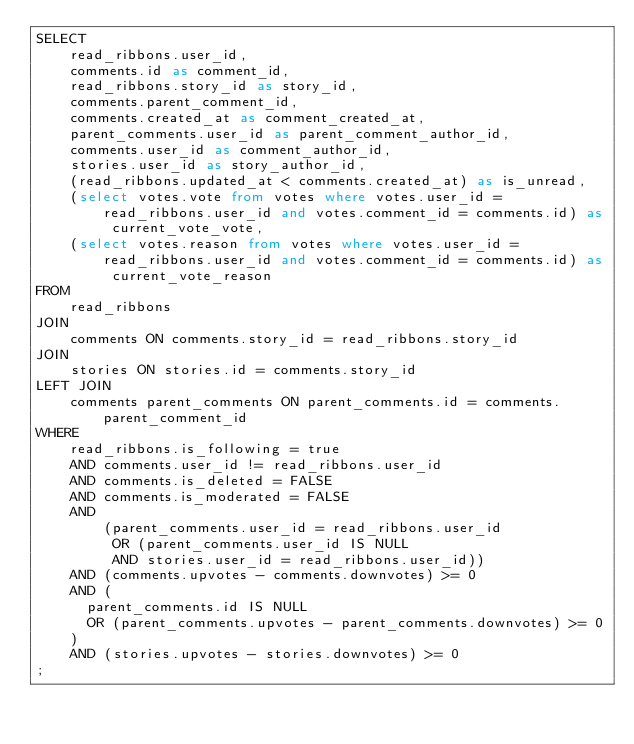<code> <loc_0><loc_0><loc_500><loc_500><_SQL_>SELECT
    read_ribbons.user_id,
    comments.id as comment_id,
    read_ribbons.story_id as story_id,
    comments.parent_comment_id,
    comments.created_at as comment_created_at,
    parent_comments.user_id as parent_comment_author_id,
    comments.user_id as comment_author_id,
    stories.user_id as story_author_id,
    (read_ribbons.updated_at < comments.created_at) as is_unread,
    (select votes.vote from votes where votes.user_id = read_ribbons.user_id and votes.comment_id = comments.id) as current_vote_vote,
    (select votes.reason from votes where votes.user_id = read_ribbons.user_id and votes.comment_id = comments.id) as current_vote_reason
FROM
    read_ribbons
JOIN
    comments ON comments.story_id = read_ribbons.story_id
JOIN
    stories ON stories.id = comments.story_id
LEFT JOIN
    comments parent_comments ON parent_comments.id = comments.parent_comment_id
WHERE
    read_ribbons.is_following = true
    AND comments.user_id != read_ribbons.user_id
    AND comments.is_deleted = FALSE
    AND comments.is_moderated = FALSE
    AND
        (parent_comments.user_id = read_ribbons.user_id
         OR (parent_comments.user_id IS NULL
         AND stories.user_id = read_ribbons.user_id))
    AND (comments.upvotes - comments.downvotes) >= 0
    AND (
      parent_comments.id IS NULL
      OR (parent_comments.upvotes - parent_comments.downvotes) >= 0
    )
    AND (stories.upvotes - stories.downvotes) >= 0
;
</code> 